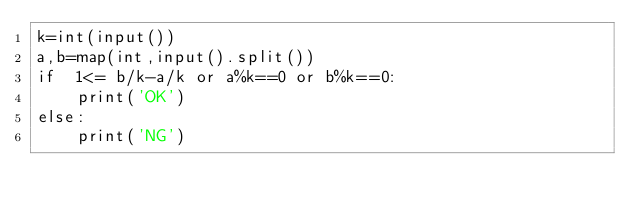Convert code to text. <code><loc_0><loc_0><loc_500><loc_500><_Python_>k=int(input())
a,b=map(int,input().split())
if  1<= b/k-a/k or a%k==0 or b%k==0:
	print('OK')
else:
	print('NG')</code> 